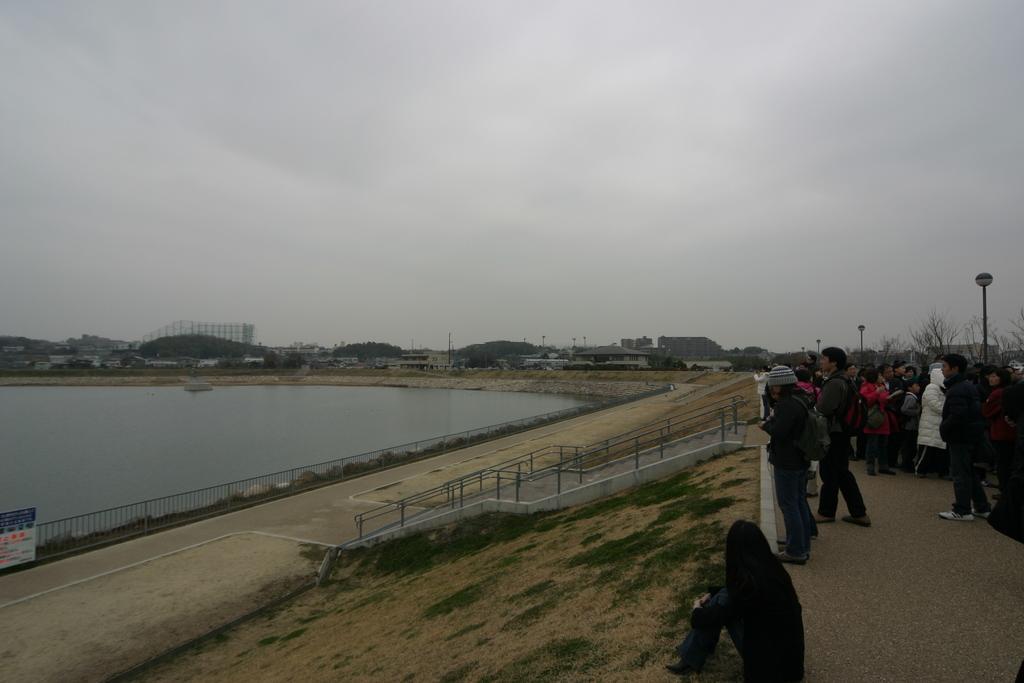Please provide a concise description of this image. In this image there are a few people standing on the road, in front of them there are stairs, railing, a board with some text and river. In the background there are buildings and the sky. 